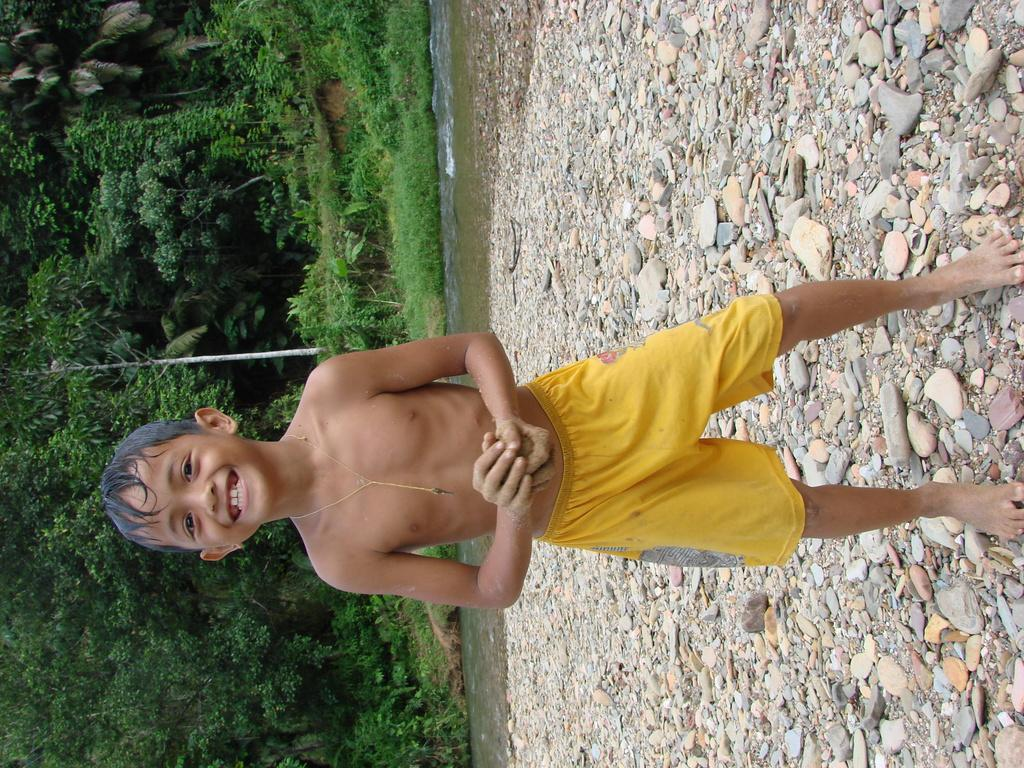What is the main subject in the middle of the image? There is a boy standing in the middle of the image. What can be seen behind the boy? There are stones, water, and grass behind the boy. Where are the trees located in the image? The trees are on the left side of the image. What type of secretary can be seen working in the image? There is no secretary present in the image; it features a boy standing in the middle of the image with a background of stones, water, and grass, and trees on the left side. What type of fold is the boy using to organize his papers in the image? There are no papers or folding activity present in the image. 